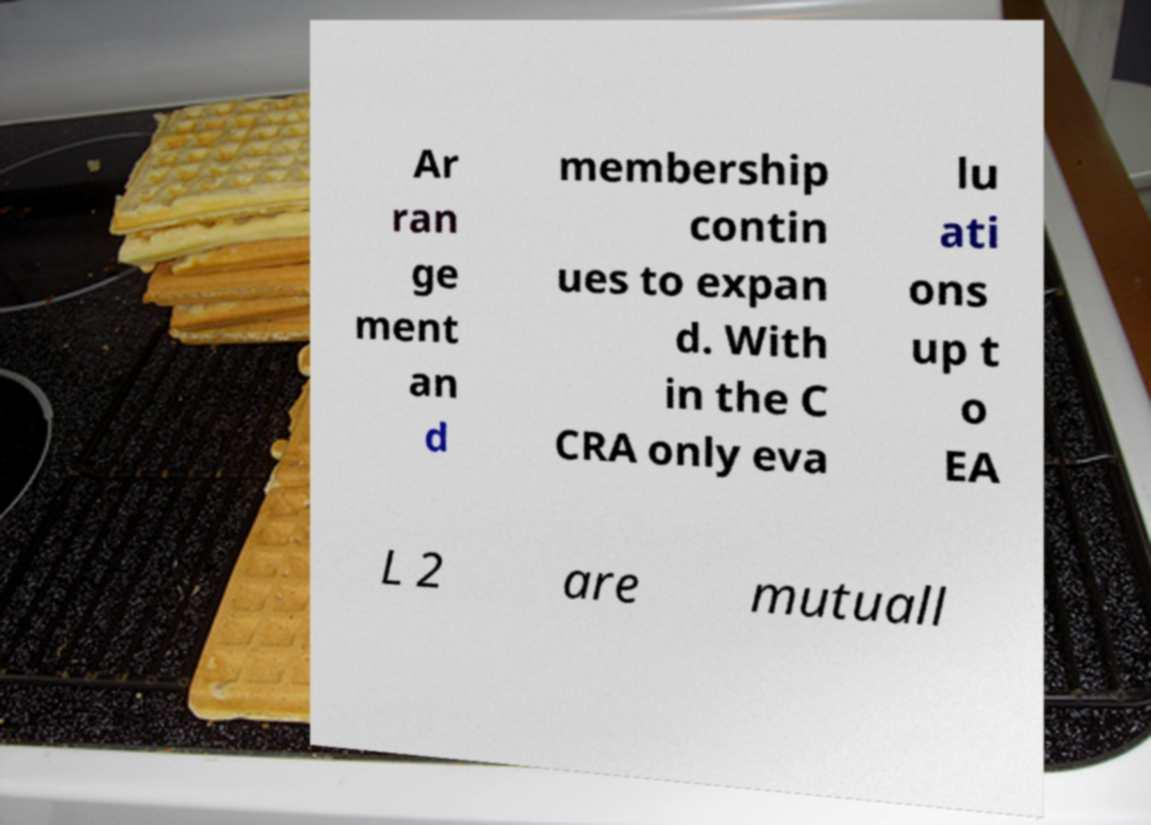I need the written content from this picture converted into text. Can you do that? Ar ran ge ment an d membership contin ues to expan d. With in the C CRA only eva lu ati ons up t o EA L 2 are mutuall 